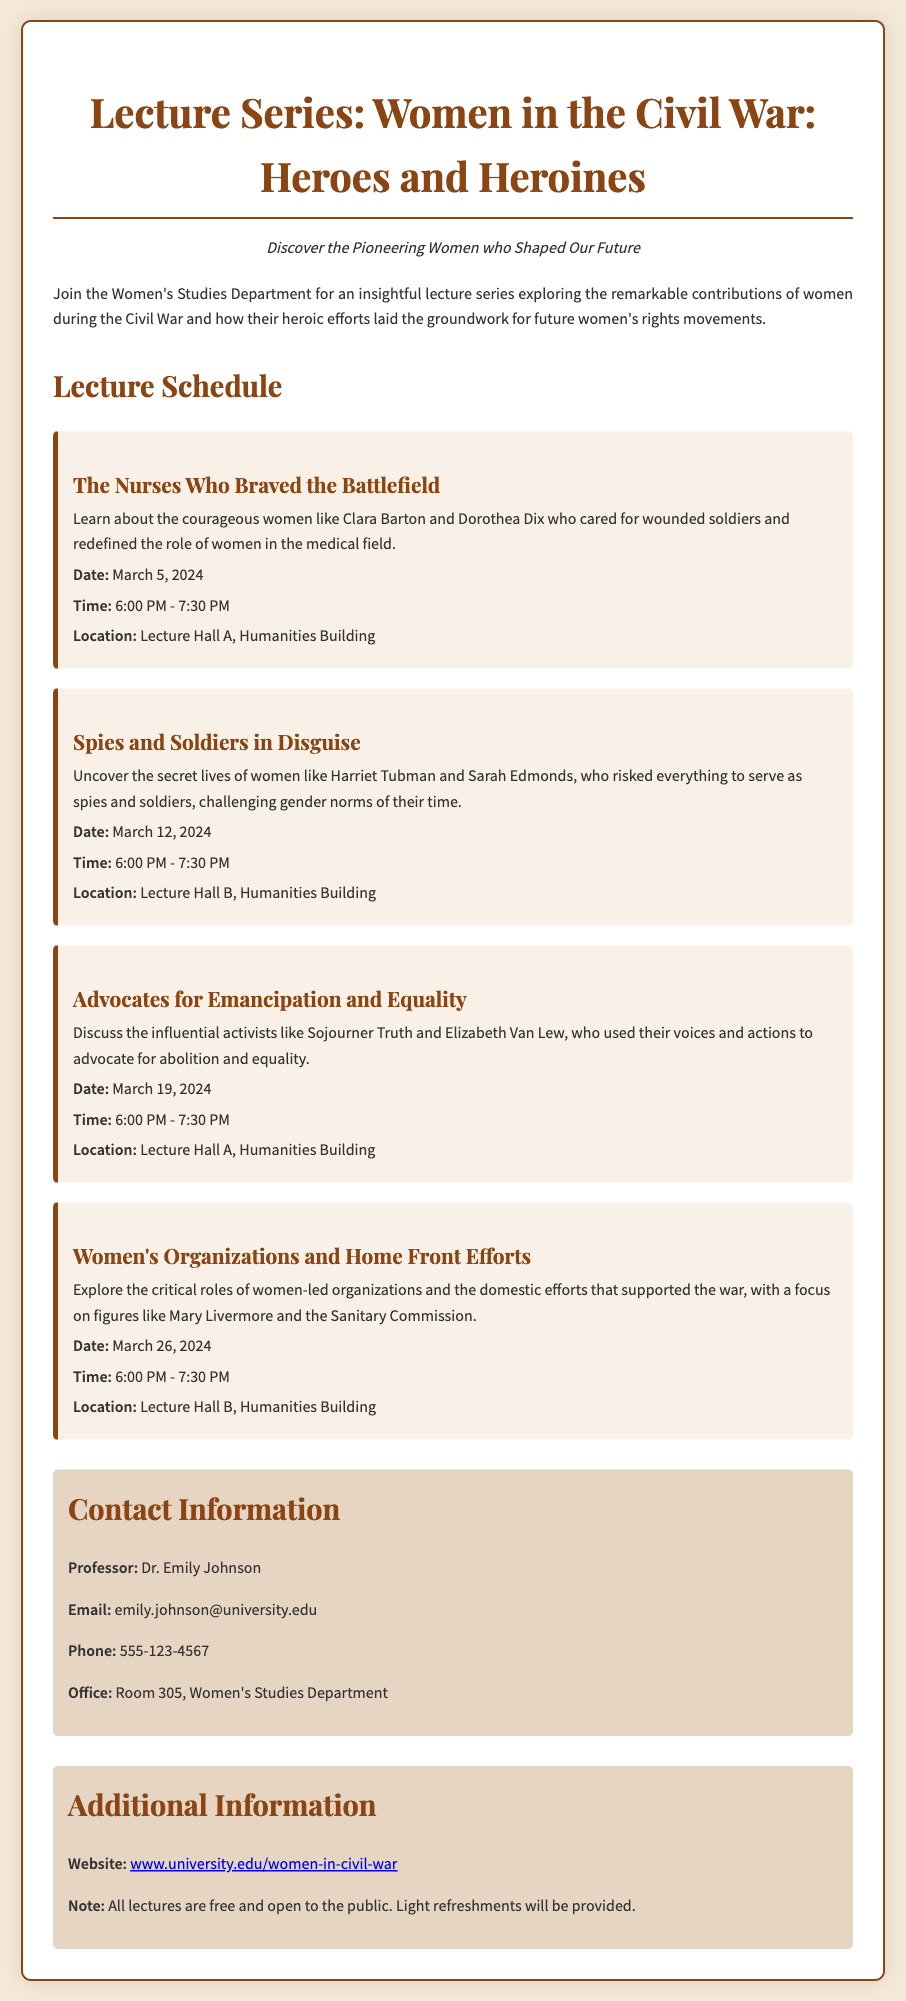What is the title of the lecture series? The title of the lecture series is stated in the header of the document.
Answer: Women in the Civil War: Heroes and Heroines Who is the contact professor for this lecture series? The contact professor's name is provided in the contact information section of the document.
Answer: Dr. Emily Johnson What is the date of the lecture on "Spies and Soldiers in Disguise"? The date for that specific lecture is listed in its detailed schedule.
Answer: March 12, 2024 How many lectures are scheduled in total? The number of lectures can be counted from the lecture schedule presented in the document.
Answer: Four What is the focus of the lecture on March 19, 2024? The focus of this lecture is clearly outlined in its description within the document.
Answer: Advocates for Emancipation and Equality Where will the lecture on "Women's Organizations and Home Front Efforts" take place? The location for this lecture is included in its specific scheduling details.
Answer: Lecture Hall B, Humanities Building What type of refreshments will be provided at the lectures? The document mentions the type of refreshments in the additional information section.
Answer: Light refreshments Which notable figure is associated with nursing during the Civil War? The document includes names of notable figures in each lecture description.
Answer: Clara Barton 